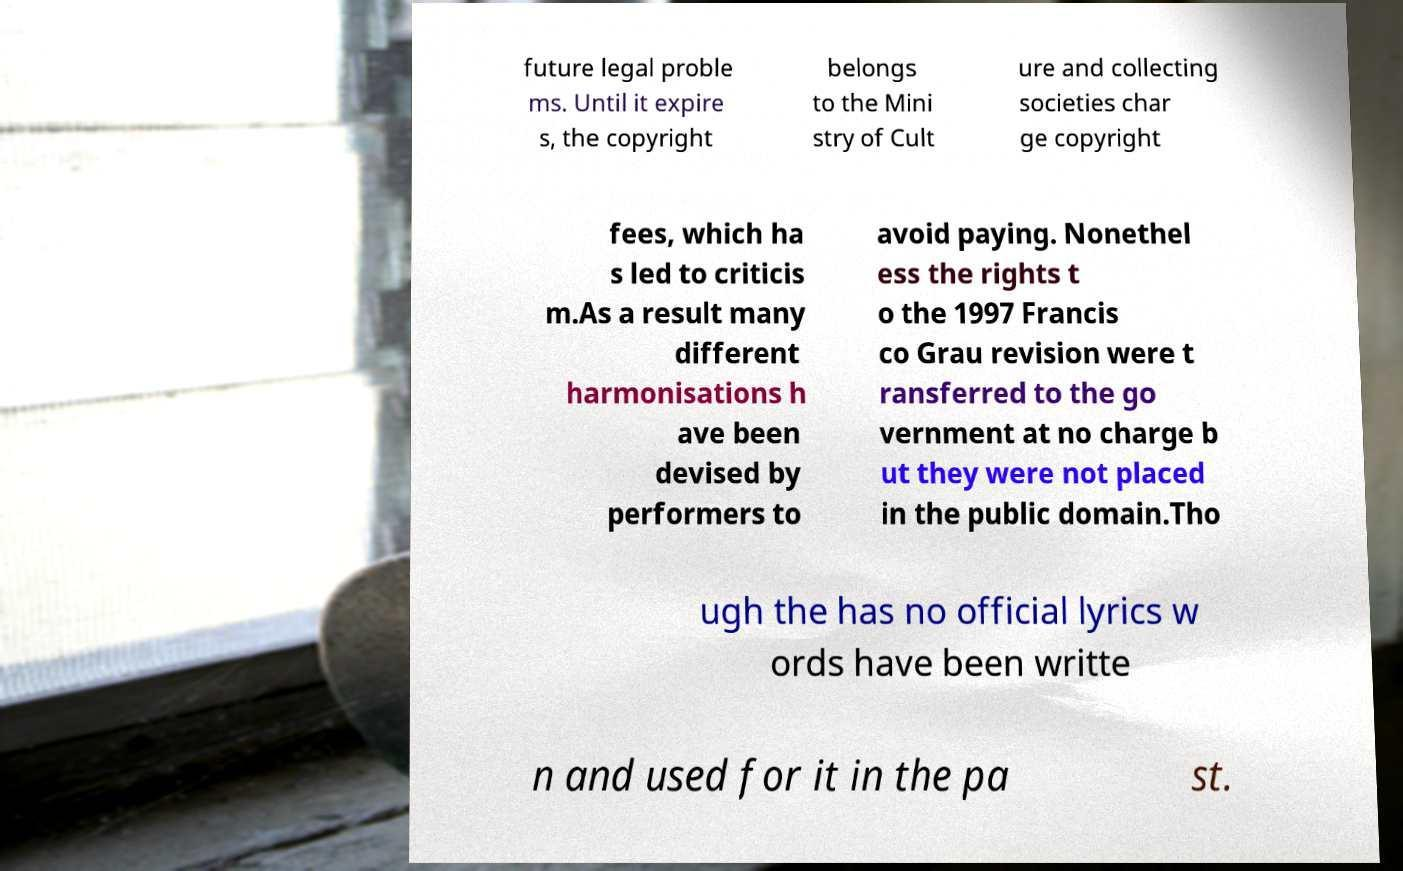There's text embedded in this image that I need extracted. Can you transcribe it verbatim? future legal proble ms. Until it expire s, the copyright belongs to the Mini stry of Cult ure and collecting societies char ge copyright fees, which ha s led to criticis m.As a result many different harmonisations h ave been devised by performers to avoid paying. Nonethel ess the rights t o the 1997 Francis co Grau revision were t ransferred to the go vernment at no charge b ut they were not placed in the public domain.Tho ugh the has no official lyrics w ords have been writte n and used for it in the pa st. 